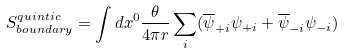Convert formula to latex. <formula><loc_0><loc_0><loc_500><loc_500>S _ { b o u n d a r y } ^ { q u i n t i c } = \int d x ^ { 0 } \frac { \theta } { 4 \pi r } \sum _ { i } ( \overline { \psi } _ { + i } \psi _ { + i } + \overline { \psi } _ { - i } \psi _ { - i } )</formula> 